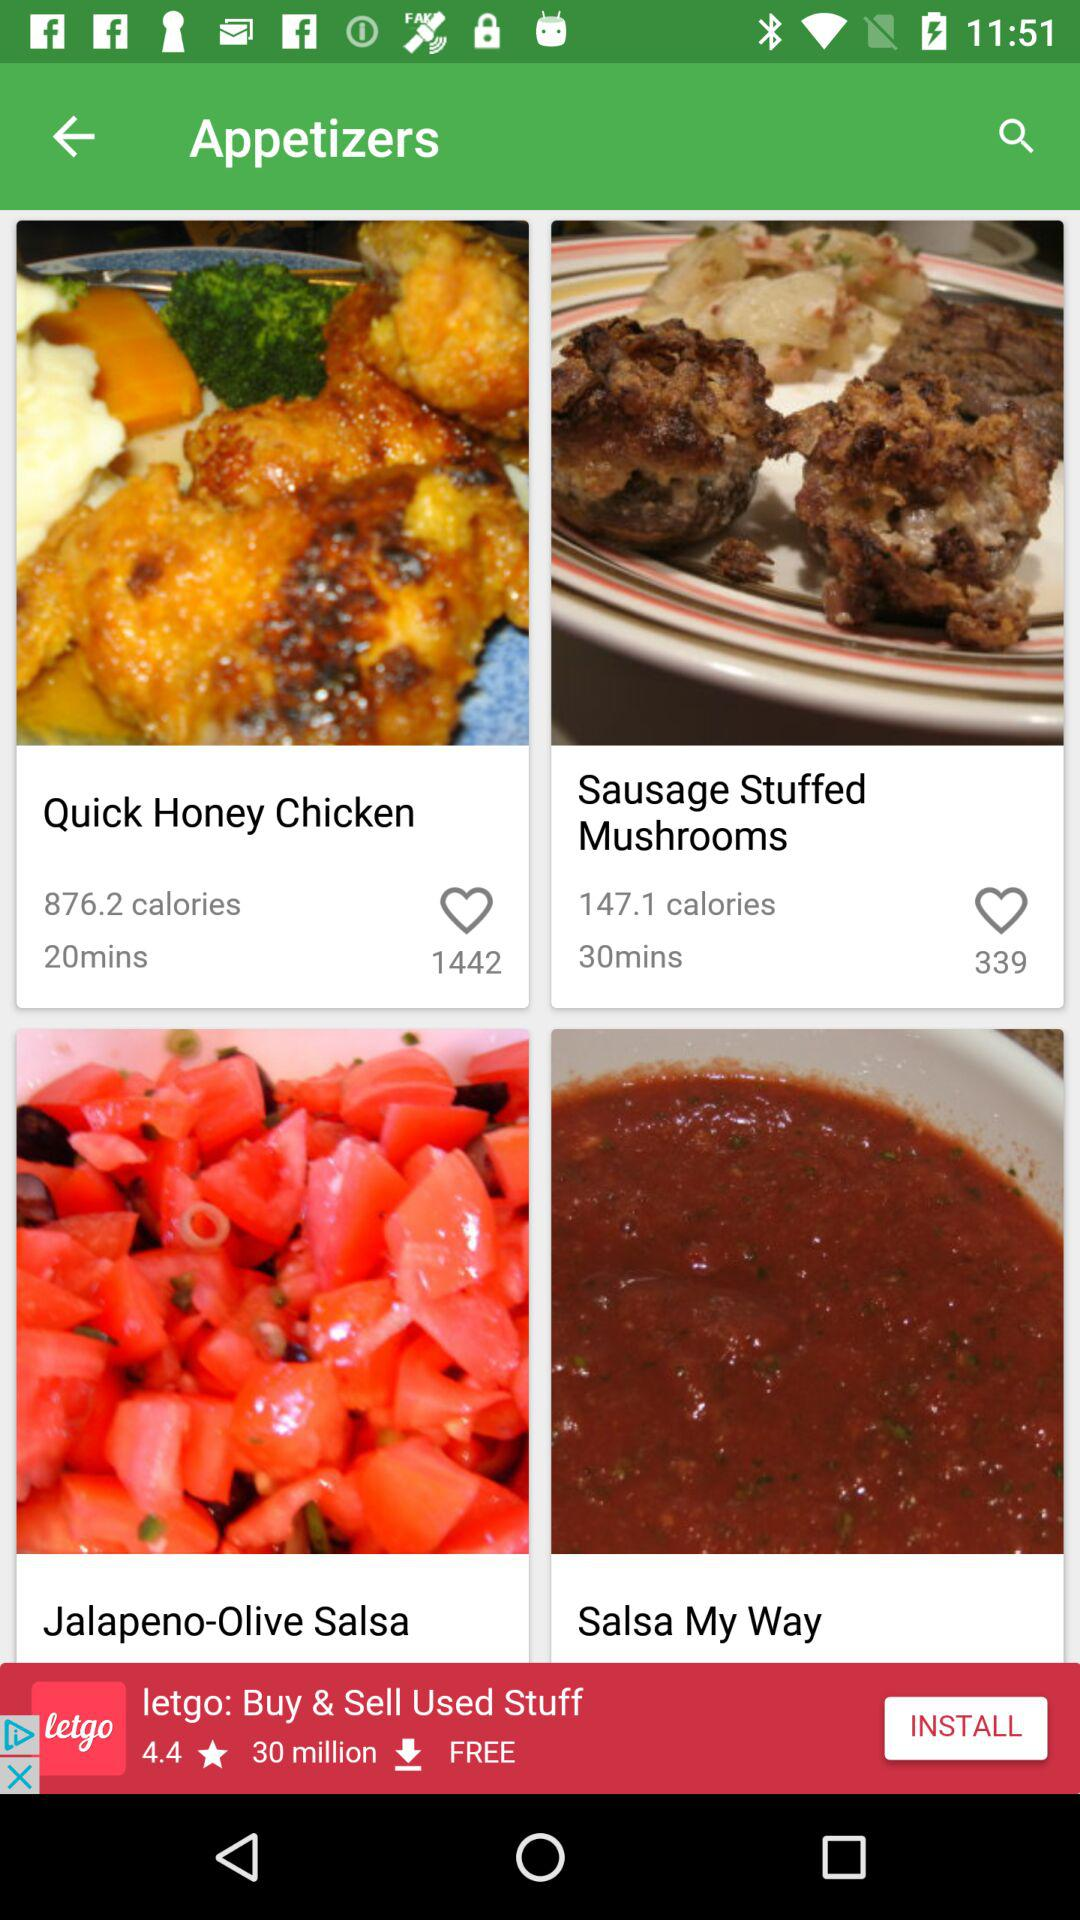How many likes are there for Quick Honey Chicken? There are 1442 likes for Quick Honey Chicken. 